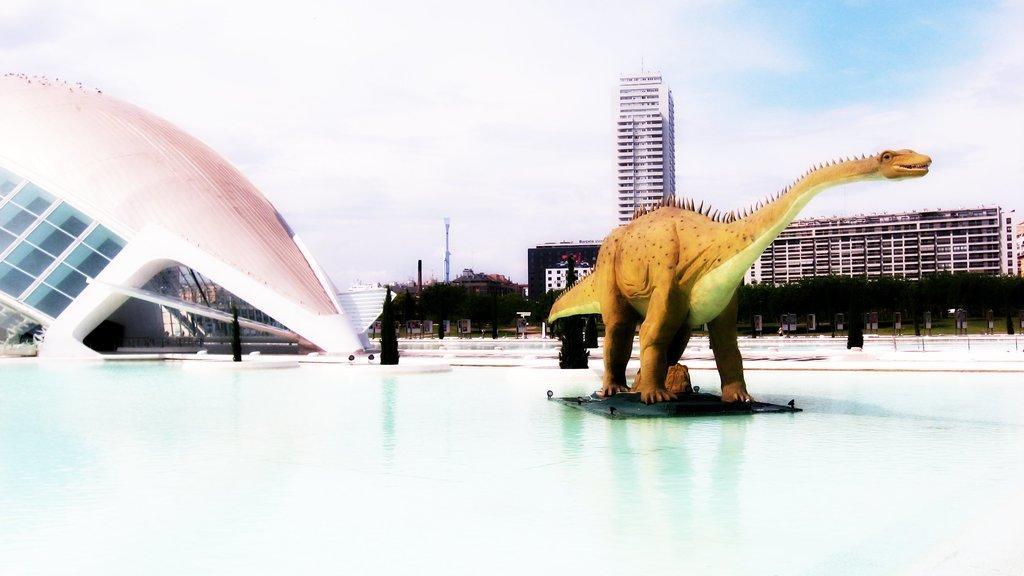Describe this image in one or two sentences. In this image there is the water. In the center of the water there is a sculpture. Behind the sculpture there are trees. In the background there are buildings, poles and trees. At the top there is the sky. 